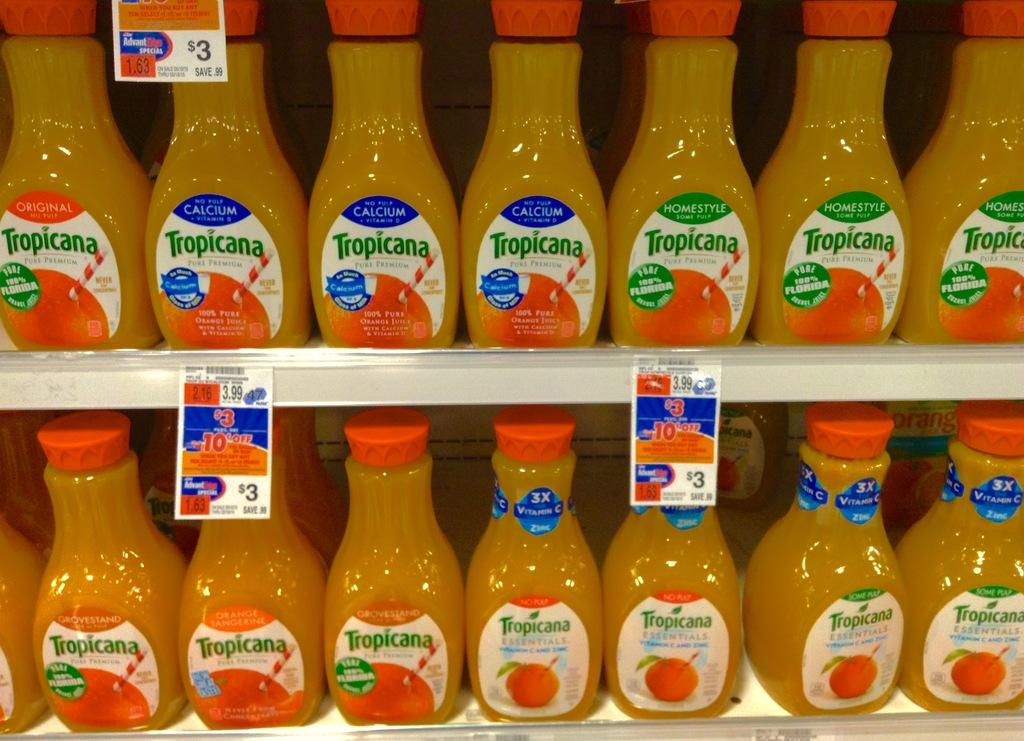Provide a one-sentence caption for the provided image. store shelves with tropicana orange juice in different varieties such as calcium, homestyle, no pulp, some pulp, and grovestand. 